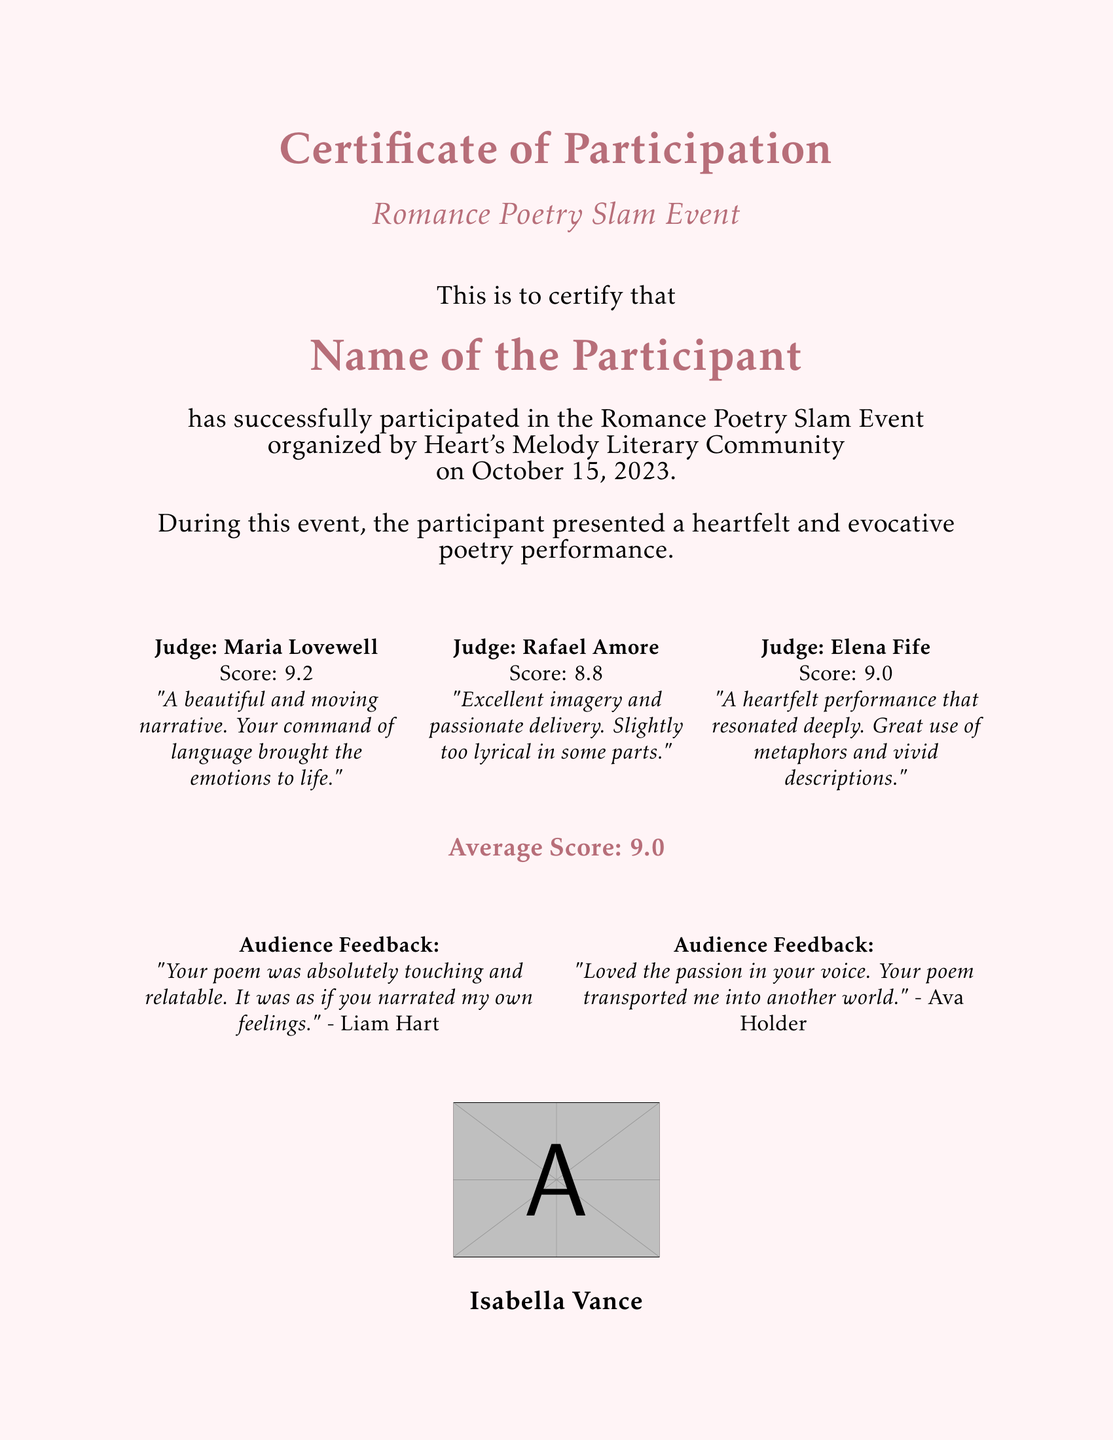What is the title of the event? The title of the event is mentioned at the beginning of the document, which is "Romance Poetry Slam Event."
Answer: Romance Poetry Slam Event When did the event take place? The date of the event is stated in the document as October 15, 2023.
Answer: October 15, 2023 Who is the Chair of the Heart's Melody Literary Community? This information can be found at the end of the document, which states that Isabella Vance is the Chair.
Answer: Isabella Vance What was the average score received by the participant? The average score is highlighted in the document, which states "Average Score: 9.0."
Answer: 9.0 How many judges provided feedback? The document lists feedback from three judges, so the number of judges is three.
Answer: Three What comment did Judge Maria Lovewell provide? The comment by Judge Maria Lovewell can be found within her section: "A beautiful and moving narrative. Your command of language brought the emotions to life."
Answer: A beautiful and moving narrative. Your command of language brought the emotions to life What is one piece of audience feedback given? The document includes audience feedback, for example, "Your poem was absolutely touching and relatable. It was as if you narrated my own feelings."
Answer: Your poem was absolutely touching and relatable. It was as if you narrated my own feelings 